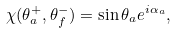Convert formula to latex. <formula><loc_0><loc_0><loc_500><loc_500>\chi ( \theta _ { a } ^ { + } , \theta _ { f } ^ { - } ) = \sin \theta _ { a } e ^ { i \alpha _ { a } } ,</formula> 